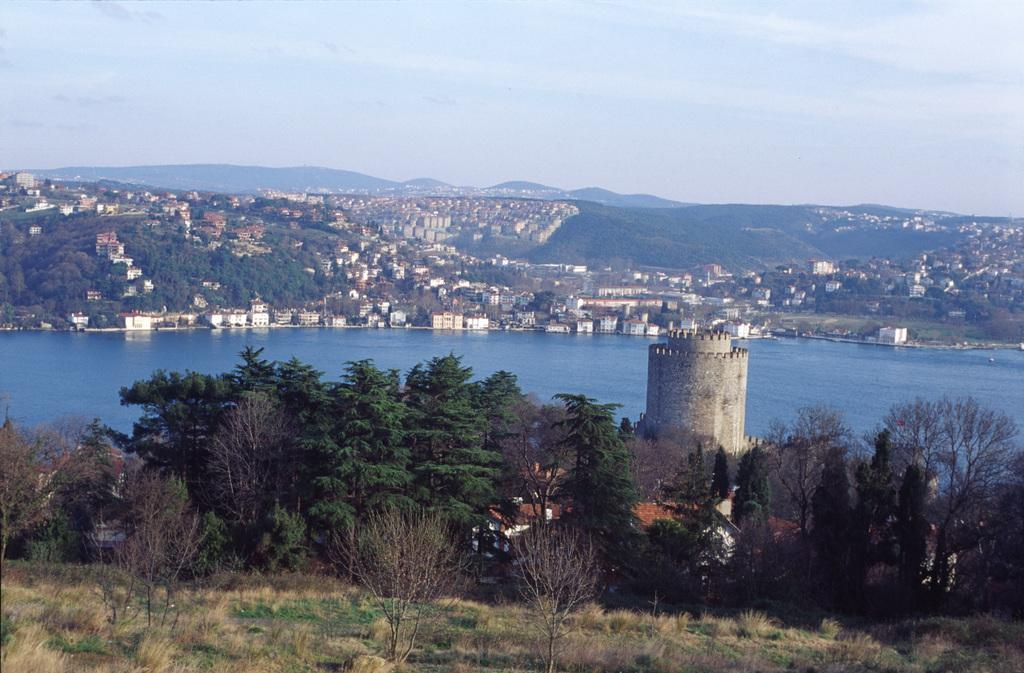What type of vegetation can be seen in the image? There are trees in the image. What else can be seen on the ground in the image? There is grass in the image. What is visible in the image besides vegetation? There is water visible in the image. What can be seen in the background of the image? There are buildings and the sky visible in the background of the image. How many clocks are hanging from the trees in the image? There are no clocks hanging from the trees in the image. What type of needle can be seen piercing the grass in the image? There is no needle present in the image. 